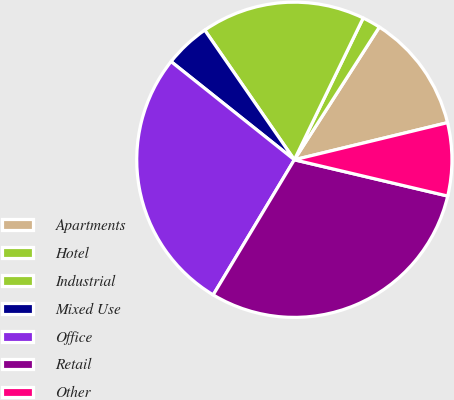Convert chart. <chart><loc_0><loc_0><loc_500><loc_500><pie_chart><fcel>Apartments<fcel>Hotel<fcel>Industrial<fcel>Mixed Use<fcel>Office<fcel>Retail<fcel>Other<nl><fcel>12.15%<fcel>1.87%<fcel>16.82%<fcel>4.67%<fcel>27.1%<fcel>29.91%<fcel>7.48%<nl></chart> 